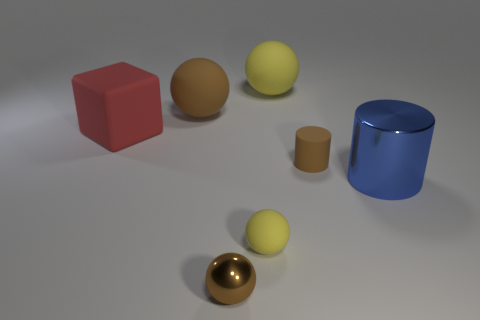Is the number of large red cubes left of the large blue thing the same as the number of brown rubber spheres that are on the right side of the shiny sphere?
Ensure brevity in your answer.  No. How many other objects are the same material as the big yellow thing?
Offer a very short reply. 4. Are there the same number of matte blocks behind the matte block and big green rubber cylinders?
Ensure brevity in your answer.  Yes. Is the size of the block the same as the matte sphere that is behind the brown matte ball?
Provide a succinct answer. Yes. There is a yellow rubber thing in front of the big blue shiny thing; what shape is it?
Offer a terse response. Sphere. Is there anything else that is the same shape as the red thing?
Your answer should be very brief. No. Are there any cyan rubber balls?
Offer a very short reply. No. There is a brown cylinder in front of the large yellow rubber ball; does it have the same size as the brown ball that is on the left side of the brown shiny sphere?
Provide a short and direct response. No. The large object that is in front of the brown rubber sphere and to the right of the red matte object is made of what material?
Your response must be concise. Metal. What number of brown cylinders are in front of the tiny metal sphere?
Offer a very short reply. 0. 